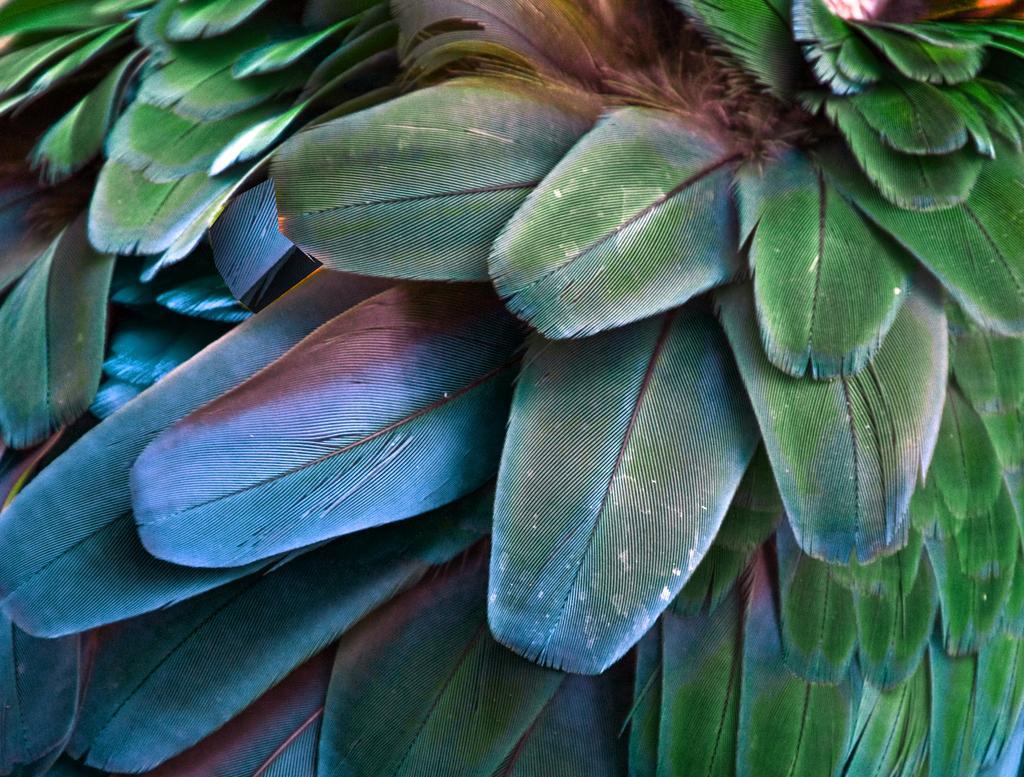Can you describe this image briefly? In this picture I can observe leaves of plants. These leaves are in green color. 